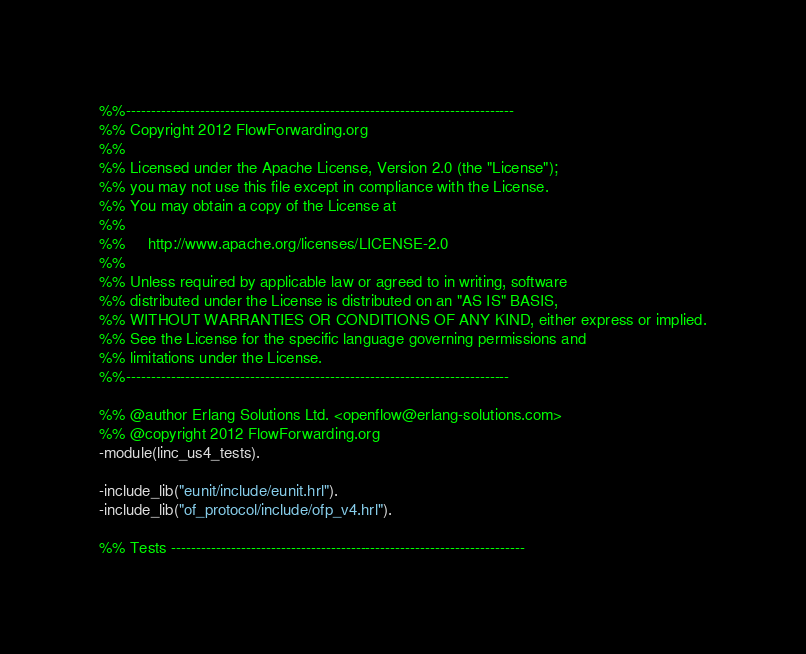Convert code to text. <code><loc_0><loc_0><loc_500><loc_500><_Erlang_>%%------------------------------------------------------------------------------
%% Copyright 2012 FlowForwarding.org
%%
%% Licensed under the Apache License, Version 2.0 (the "License");
%% you may not use this file except in compliance with the License.
%% You may obtain a copy of the License at
%%
%%     http://www.apache.org/licenses/LICENSE-2.0
%%
%% Unless required by applicable law or agreed to in writing, software
%% distributed under the License is distributed on an "AS IS" BASIS,
%% WITHOUT WARRANTIES OR CONDITIONS OF ANY KIND, either express or implied.
%% See the License for the specific language governing permissions and
%% limitations under the License.
%%-----------------------------------------------------------------------------

%% @author Erlang Solutions Ltd. <openflow@erlang-solutions.com>
%% @copyright 2012 FlowForwarding.org
-module(linc_us4_tests).

-include_lib("eunit/include/eunit.hrl").
-include_lib("of_protocol/include/ofp_v4.hrl").

%% Tests -----------------------------------------------------------------------
</code> 